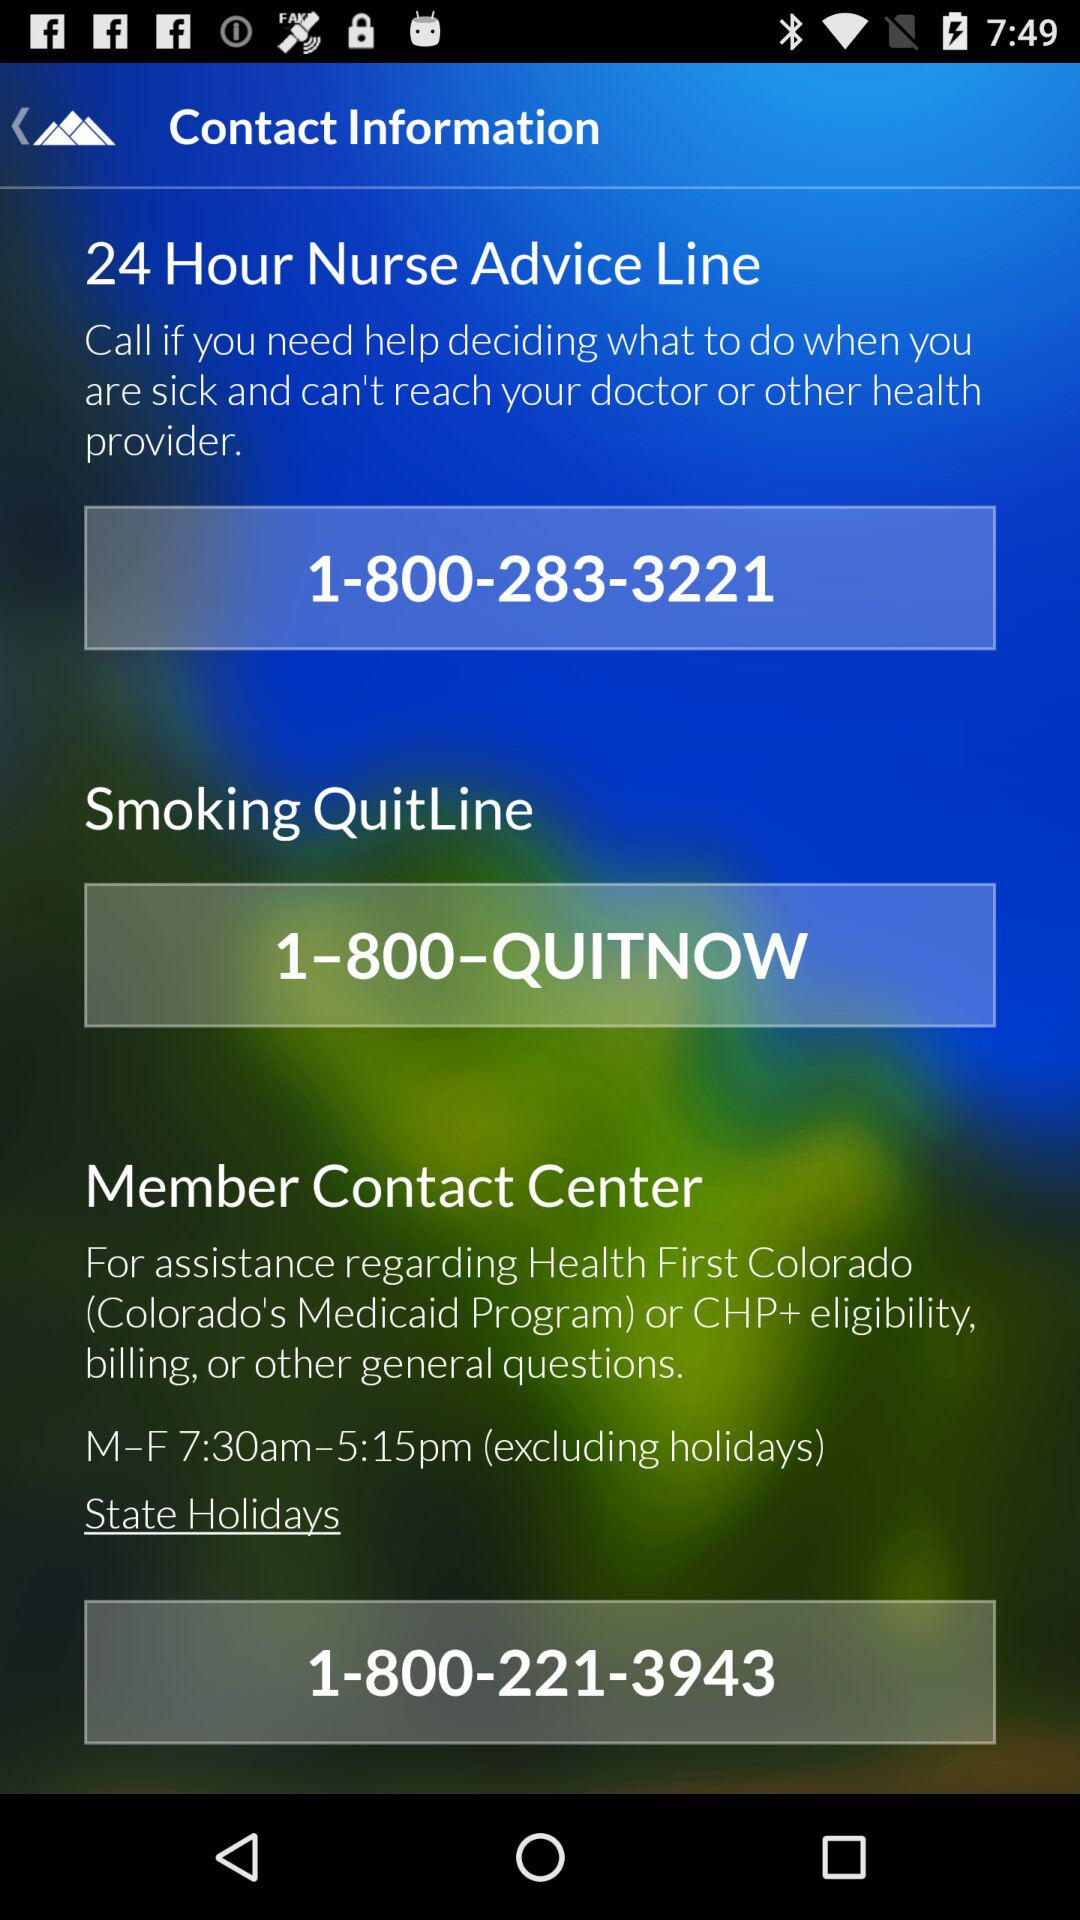How many contact information items are there?
Answer the question using a single word or phrase. 3 